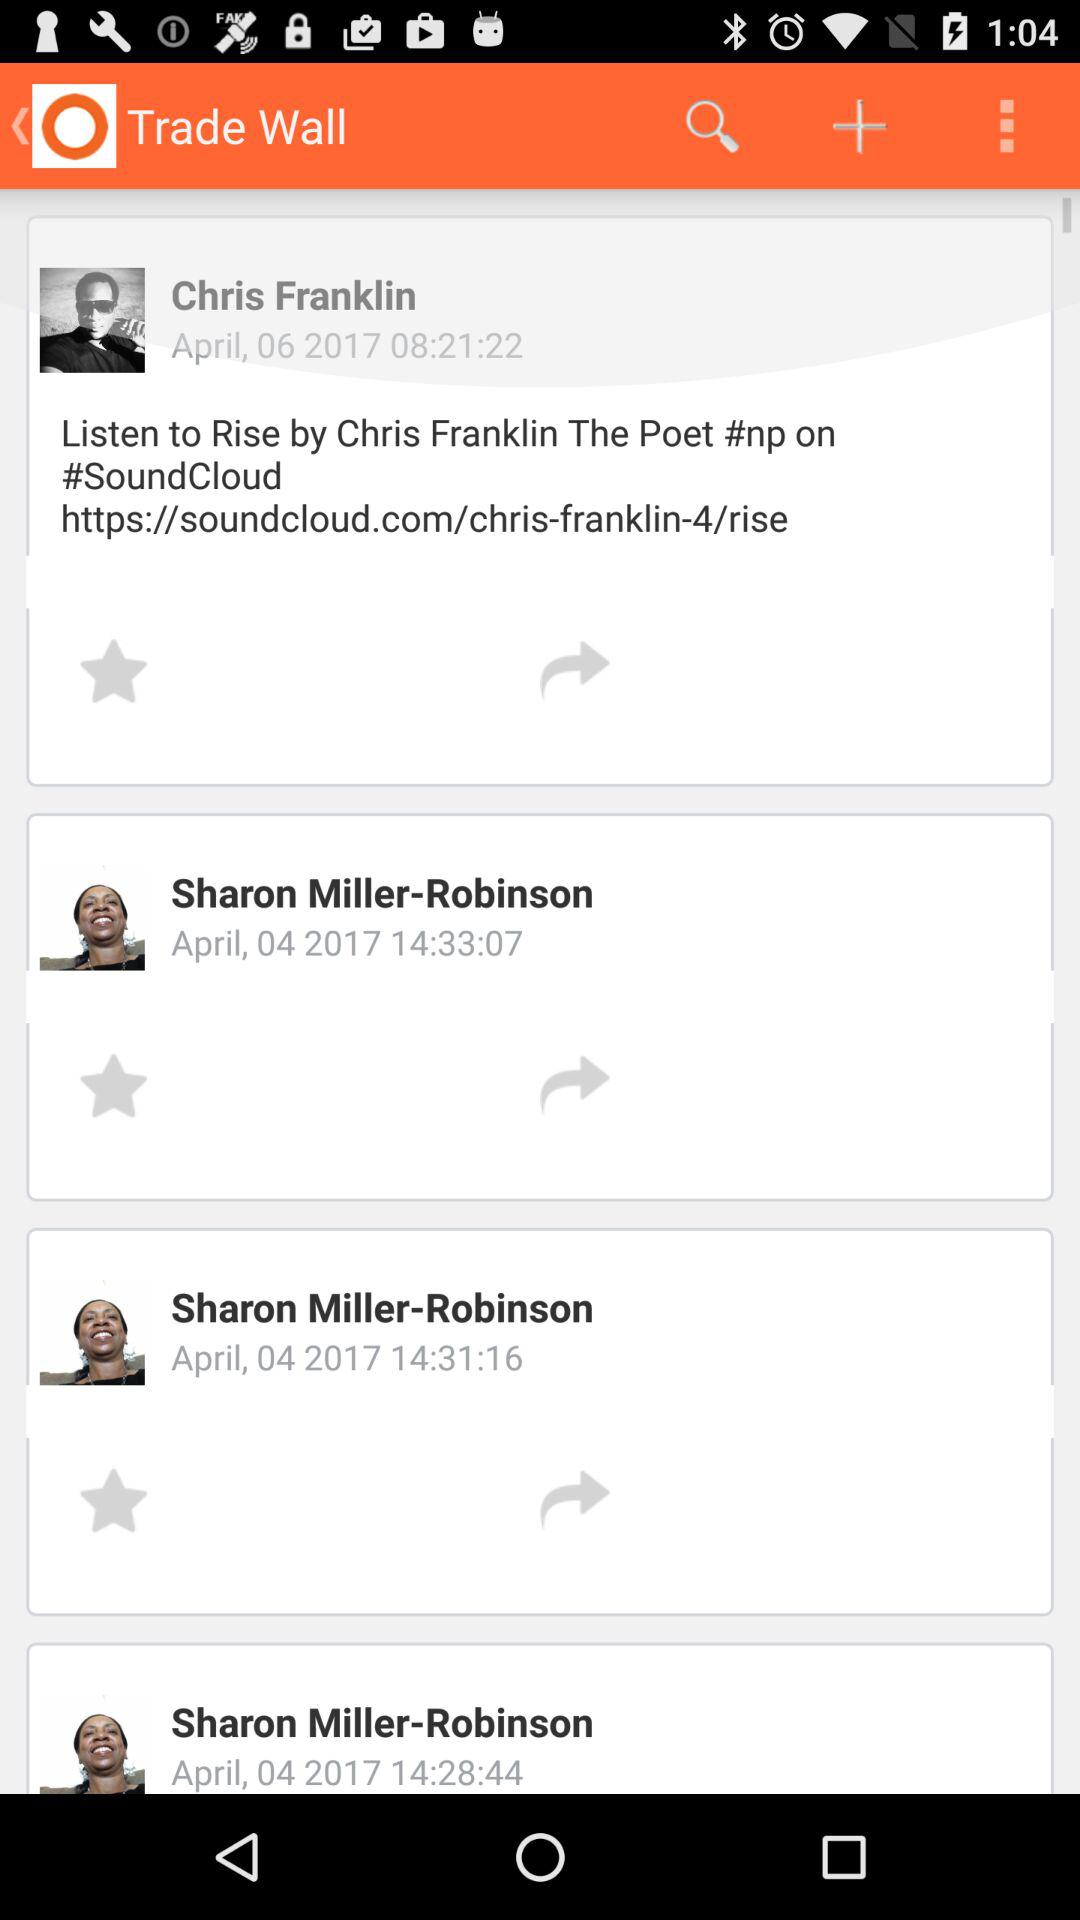At what time did Chris Franklin update a post? The post was updated at 08:21:22. 